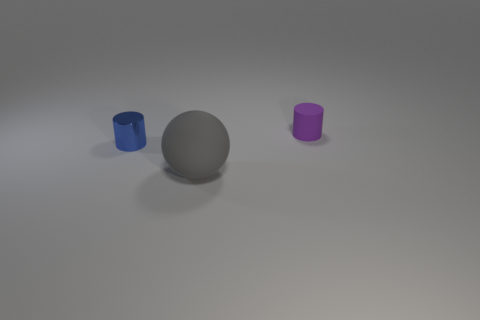Add 1 purple blocks. How many objects exist? 4 Subtract all cylinders. How many objects are left? 1 Subtract all purple cylinders. Subtract all metal cylinders. How many objects are left? 1 Add 2 small objects. How many small objects are left? 4 Add 2 gray balls. How many gray balls exist? 3 Subtract 0 yellow spheres. How many objects are left? 3 